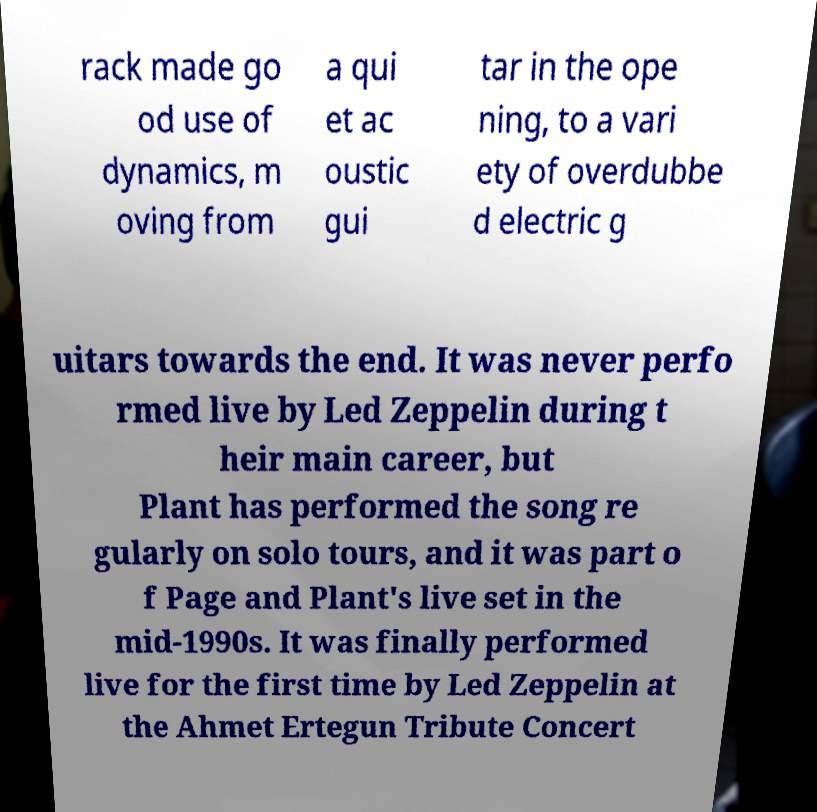Can you accurately transcribe the text from the provided image for me? rack made go od use of dynamics, m oving from a qui et ac oustic gui tar in the ope ning, to a vari ety of overdubbe d electric g uitars towards the end. It was never perfo rmed live by Led Zeppelin during t heir main career, but Plant has performed the song re gularly on solo tours, and it was part o f Page and Plant's live set in the mid-1990s. It was finally performed live for the first time by Led Zeppelin at the Ahmet Ertegun Tribute Concert 